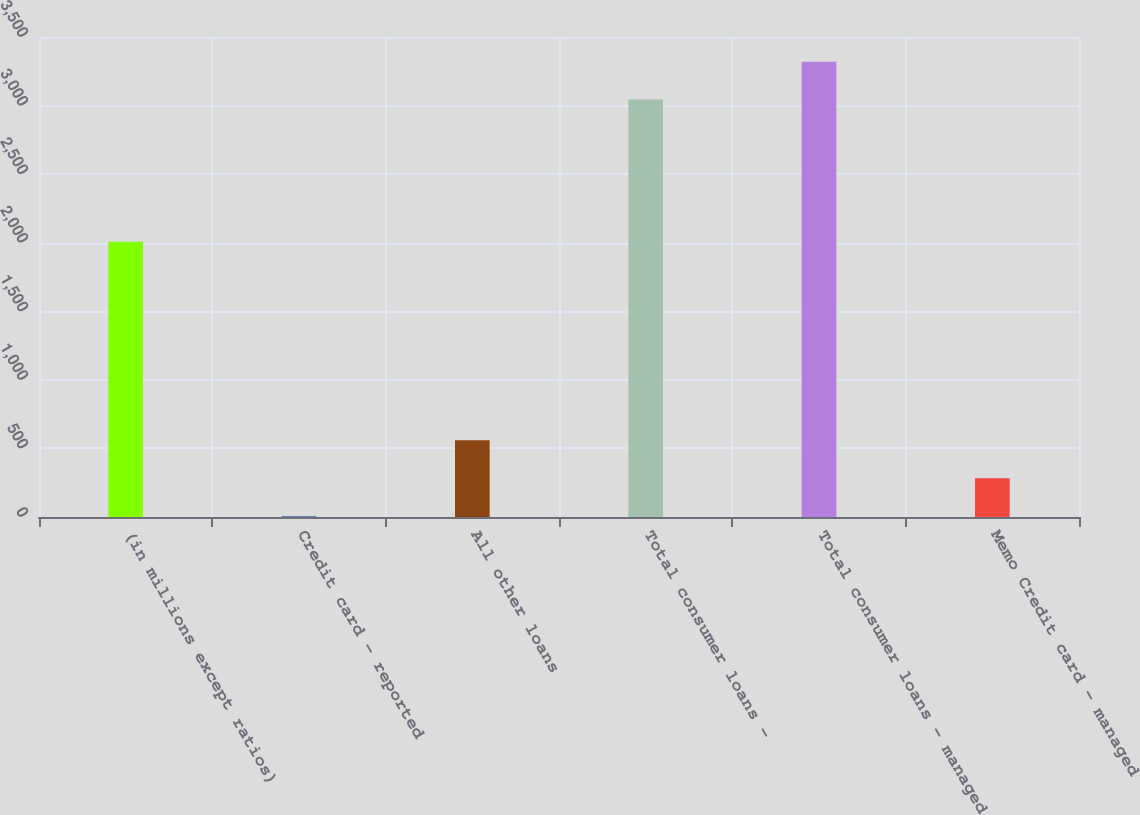<chart> <loc_0><loc_0><loc_500><loc_500><bar_chart><fcel>(in millions except ratios)<fcel>Credit card - reported<fcel>All other loans<fcel>Total consumer loans -<fcel>Total consumer loans - managed<fcel>Memo Credit card - managed<nl><fcel>2007<fcel>7<fcel>559.2<fcel>3044.1<fcel>3320.2<fcel>283.1<nl></chart> 